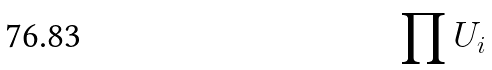Convert formula to latex. <formula><loc_0><loc_0><loc_500><loc_500>\prod U _ { i }</formula> 